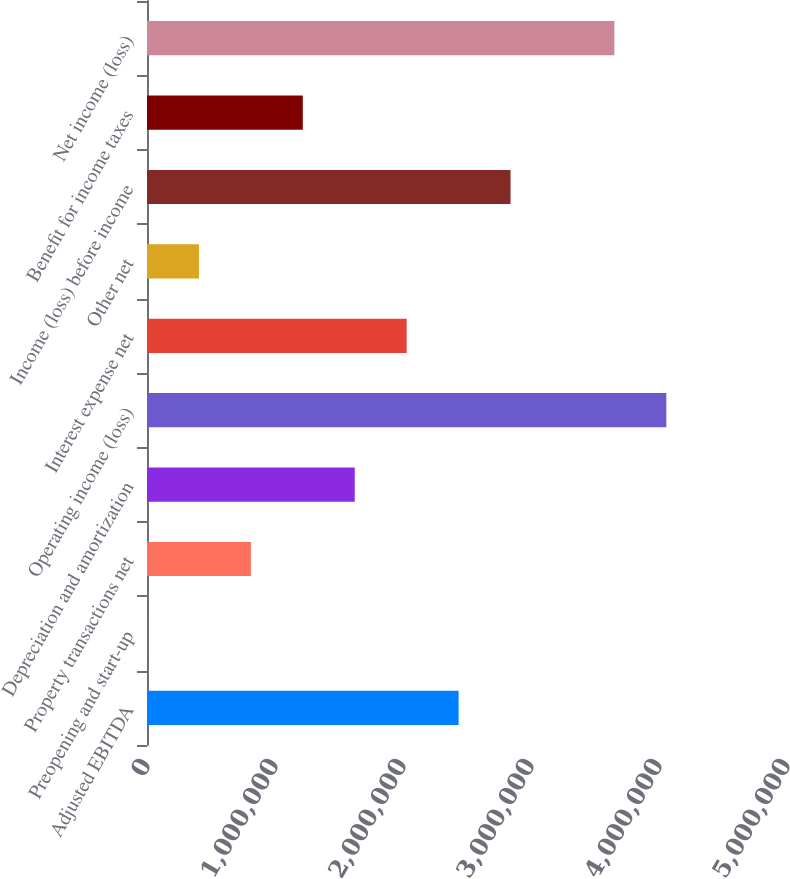Convert chart. <chart><loc_0><loc_0><loc_500><loc_500><bar_chart><fcel>Adjusted EBITDA<fcel>Preopening and start-up<fcel>Property transactions net<fcel>Depreciation and amortization<fcel>Operating income (loss)<fcel>Interest expense net<fcel>Other net<fcel>Income (loss) before income<fcel>Benefit for income taxes<fcel>Net income (loss)<nl><fcel>2.43441e+06<fcel>316<fcel>811682<fcel>1.62305e+06<fcel>4.05715e+06<fcel>2.02873e+06<fcel>405999<fcel>2.8401e+06<fcel>1.21736e+06<fcel>3.65146e+06<nl></chart> 